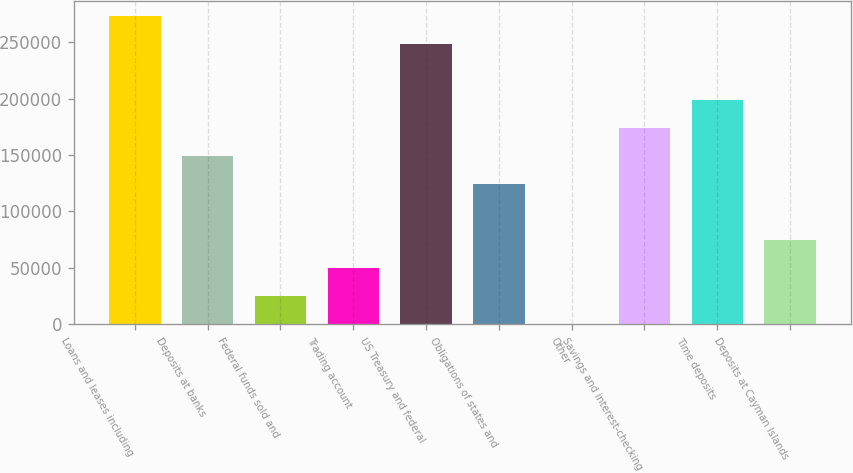Convert chart to OTSL. <chart><loc_0><loc_0><loc_500><loc_500><bar_chart><fcel>Loans and leases including<fcel>Deposits at banks<fcel>Federal funds sold and<fcel>Trading account<fcel>US Treasury and federal<fcel>Obligations of states and<fcel>Other<fcel>Savings and interest-checking<fcel>Time deposits<fcel>Deposits at Cayman Islands<nl><fcel>272929<fcel>148879<fcel>24829.9<fcel>49639.8<fcel>248119<fcel>124070<fcel>20<fcel>173689<fcel>198499<fcel>74449.7<nl></chart> 